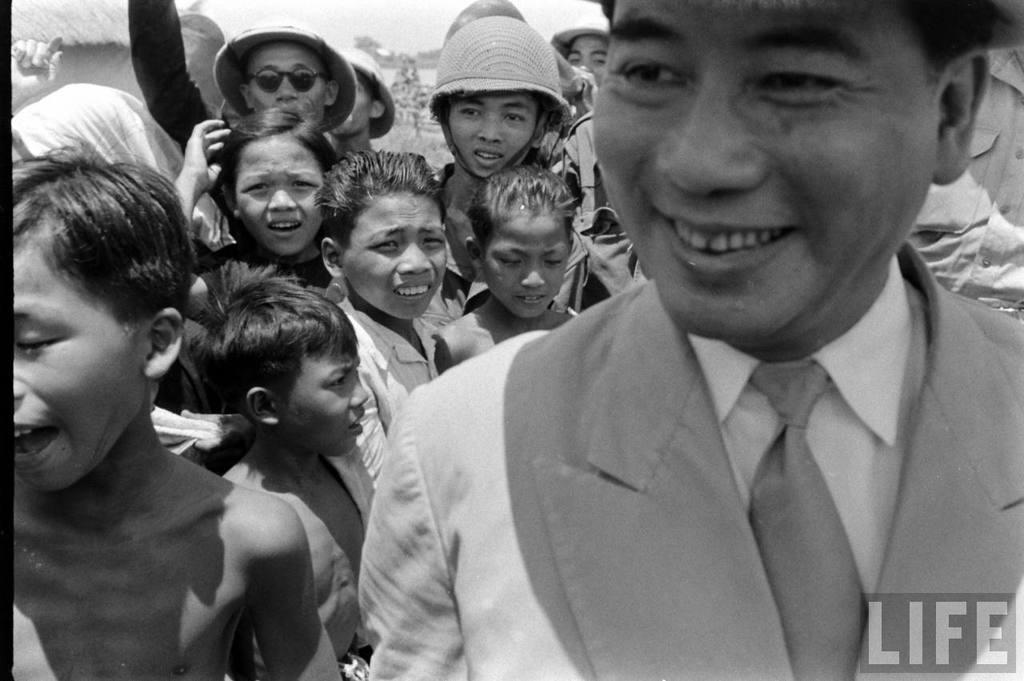What can be seen in the image? There are kids in the image. What is the color scheme of the image? The image is black and white. Where is the person located in the image? The person is on the right side of the image. What is the person wearing? The person is wearing clothes. What is present in the bottom right of the image? There is text in the bottom right of the image. What type of rings can be seen on the kids' fingers in the image? There are no rings visible on the kids' fingers in the image. How does the person start the activity in the image? The image does not depict an activity being started, nor does it show the person in the act of starting something. 